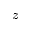Convert formula to latex. <formula><loc_0><loc_0><loc_500><loc_500>z</formula> 